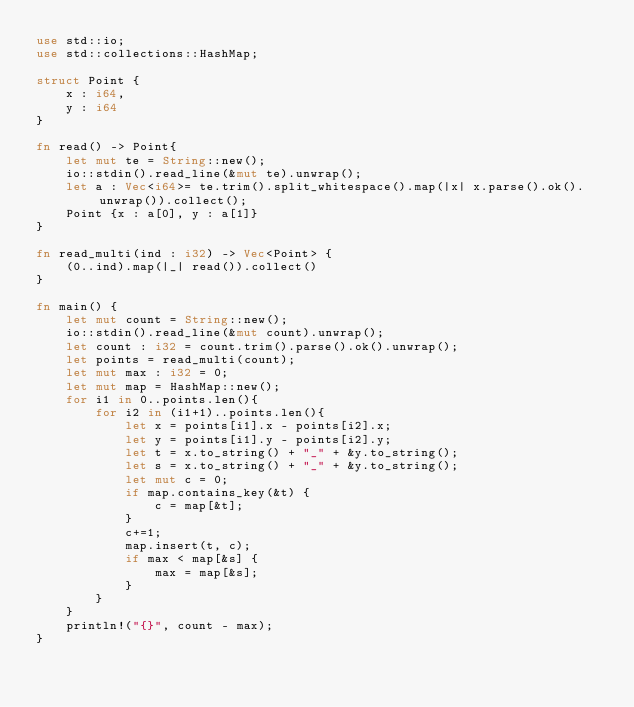<code> <loc_0><loc_0><loc_500><loc_500><_Rust_>use std::io;
use std::collections::HashMap;

struct Point {
    x : i64,
    y : i64
}

fn read() -> Point{
    let mut te = String::new();
    io::stdin().read_line(&mut te).unwrap();
    let a : Vec<i64>= te.trim().split_whitespace().map(|x| x.parse().ok().unwrap()).collect();
    Point {x : a[0], y : a[1]}
}

fn read_multi(ind : i32) -> Vec<Point> {
    (0..ind).map(|_| read()).collect()
}

fn main() {
    let mut count = String::new();
    io::stdin().read_line(&mut count).unwrap();
    let count : i32 = count.trim().parse().ok().unwrap();
    let points = read_multi(count);
    let mut max : i32 = 0;
    let mut map = HashMap::new();
    for i1 in 0..points.len(){
        for i2 in (i1+1)..points.len(){
            let x = points[i1].x - points[i2].x;
            let y = points[i1].y - points[i2].y;
            let t = x.to_string() + "_" + &y.to_string();
            let s = x.to_string() + "_" + &y.to_string();
            let mut c = 0;
            if map.contains_key(&t) {
                c = map[&t];
            }
            c+=1;
            map.insert(t, c);
            if max < map[&s] {
                max = map[&s];
            }
        }
    }
    println!("{}", count - max);
}</code> 